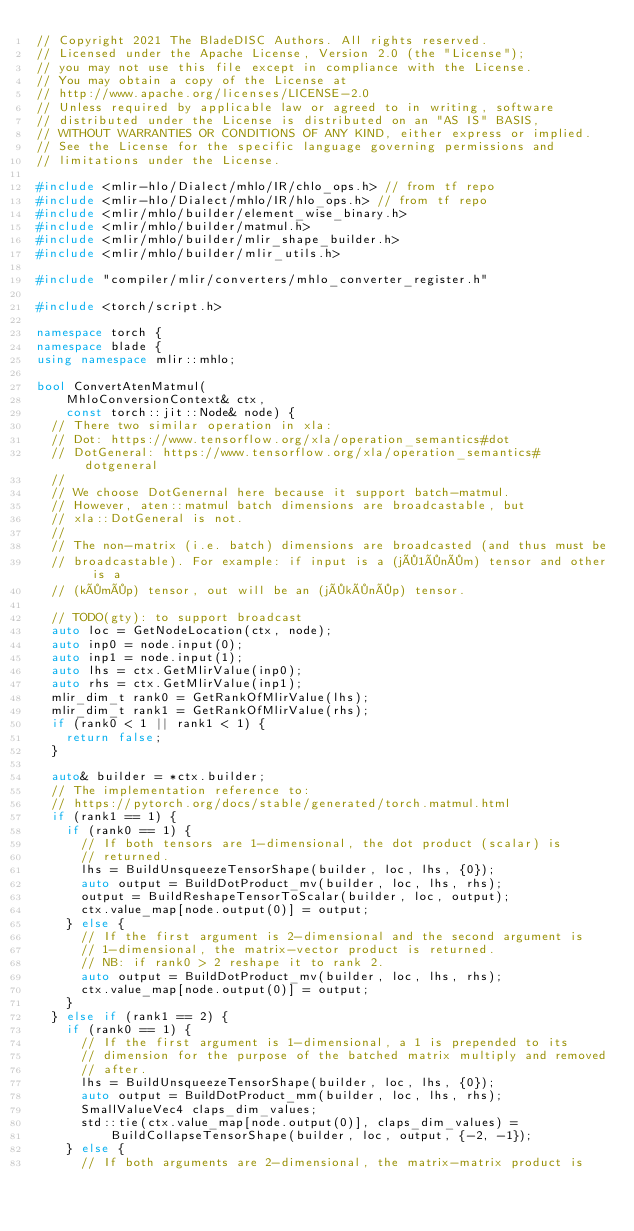<code> <loc_0><loc_0><loc_500><loc_500><_C++_>// Copyright 2021 The BladeDISC Authors. All rights reserved.
// Licensed under the Apache License, Version 2.0 (the "License");
// you may not use this file except in compliance with the License.
// You may obtain a copy of the License at
// http://www.apache.org/licenses/LICENSE-2.0
// Unless required by applicable law or agreed to in writing, software
// distributed under the License is distributed on an "AS IS" BASIS,
// WITHOUT WARRANTIES OR CONDITIONS OF ANY KIND, either express or implied.
// See the License for the specific language governing permissions and
// limitations under the License.

#include <mlir-hlo/Dialect/mhlo/IR/chlo_ops.h> // from tf repo
#include <mlir-hlo/Dialect/mhlo/IR/hlo_ops.h> // from tf repo
#include <mlir/mhlo/builder/element_wise_binary.h>
#include <mlir/mhlo/builder/matmul.h>
#include <mlir/mhlo/builder/mlir_shape_builder.h>
#include <mlir/mhlo/builder/mlir_utils.h>

#include "compiler/mlir/converters/mhlo_converter_register.h"

#include <torch/script.h>

namespace torch {
namespace blade {
using namespace mlir::mhlo;

bool ConvertAtenMatmul(
    MhloConversionContext& ctx,
    const torch::jit::Node& node) {
  // There two similar operation in xla:
  // Dot: https://www.tensorflow.org/xla/operation_semantics#dot
  // DotGeneral: https://www.tensorflow.org/xla/operation_semantics#dotgeneral
  //
  // We choose DotGenernal here because it support batch-matmul.
  // However, aten::matmul batch dimensions are broadcastable, but
  // xla::DotGeneral is not.
  //
  // The non-matrix (i.e. batch) dimensions are broadcasted (and thus must be
  // broadcastable). For example: if input is a (j×1×n×m) tensor and other is a
  // (k×m×p) tensor, out will be an (j×k×n×p) tensor.

  // TODO(gty): to support broadcast
  auto loc = GetNodeLocation(ctx, node);
  auto inp0 = node.input(0);
  auto inp1 = node.input(1);
  auto lhs = ctx.GetMlirValue(inp0);
  auto rhs = ctx.GetMlirValue(inp1);
  mlir_dim_t rank0 = GetRankOfMlirValue(lhs);
  mlir_dim_t rank1 = GetRankOfMlirValue(rhs);
  if (rank0 < 1 || rank1 < 1) {
    return false;
  }

  auto& builder = *ctx.builder;
  // The implementation reference to:
  // https://pytorch.org/docs/stable/generated/torch.matmul.html
  if (rank1 == 1) {
    if (rank0 == 1) {
      // If both tensors are 1-dimensional, the dot product (scalar) is
      // returned.
      lhs = BuildUnsqueezeTensorShape(builder, loc, lhs, {0});
      auto output = BuildDotProduct_mv(builder, loc, lhs, rhs);
      output = BuildReshapeTensorToScalar(builder, loc, output);
      ctx.value_map[node.output(0)] = output;
    } else {
      // If the first argument is 2-dimensional and the second argument is
      // 1-dimensional, the matrix-vector product is returned.
      // NB: if rank0 > 2 reshape it to rank 2.
      auto output = BuildDotProduct_mv(builder, loc, lhs, rhs);
      ctx.value_map[node.output(0)] = output;
    }
  } else if (rank1 == 2) {
    if (rank0 == 1) {
      // If the first argument is 1-dimensional, a 1 is prepended to its
      // dimension for the purpose of the batched matrix multiply and removed
      // after.
      lhs = BuildUnsqueezeTensorShape(builder, loc, lhs, {0});
      auto output = BuildDotProduct_mm(builder, loc, lhs, rhs);
      SmallValueVec4 claps_dim_values;
      std::tie(ctx.value_map[node.output(0)], claps_dim_values) =
          BuildCollapseTensorShape(builder, loc, output, {-2, -1});
    } else {
      // If both arguments are 2-dimensional, the matrix-matrix product is</code> 